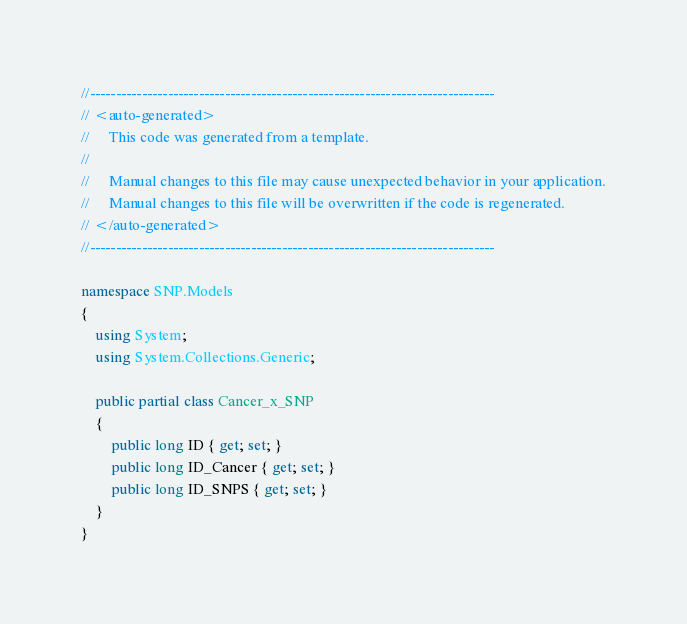Convert code to text. <code><loc_0><loc_0><loc_500><loc_500><_C#_>//------------------------------------------------------------------------------
// <auto-generated>
//     This code was generated from a template.
//
//     Manual changes to this file may cause unexpected behavior in your application.
//     Manual changes to this file will be overwritten if the code is regenerated.
// </auto-generated>
//------------------------------------------------------------------------------

namespace SNP.Models
{
    using System;
    using System.Collections.Generic;
    
    public partial class Cancer_x_SNP
    {
        public long ID { get; set; }
        public long ID_Cancer { get; set; }
        public long ID_SNPS { get; set; }
    }
}
</code> 